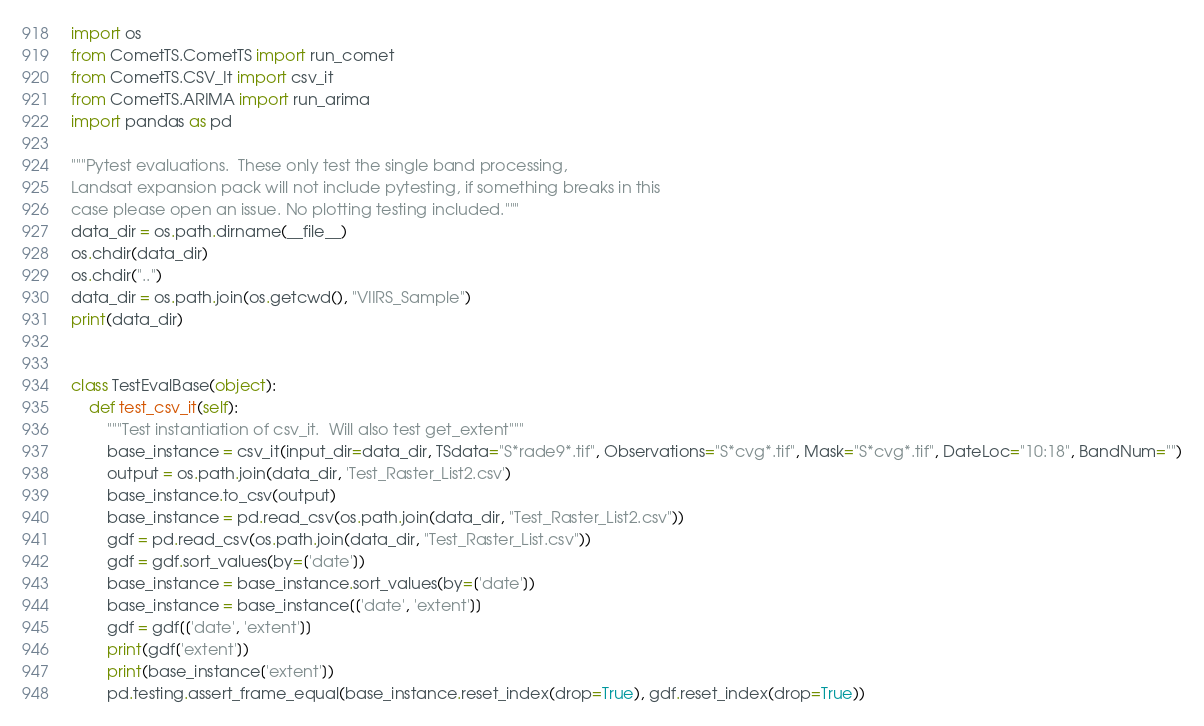Convert code to text. <code><loc_0><loc_0><loc_500><loc_500><_Python_>import os
from CometTS.CometTS import run_comet
from CometTS.CSV_It import csv_it
from CometTS.ARIMA import run_arima
import pandas as pd

"""Pytest evaluations.  These only test the single band processing,
Landsat expansion pack will not include pytesting, if something breaks in this
case please open an issue. No plotting testing included."""
data_dir = os.path.dirname(__file__)
os.chdir(data_dir)
os.chdir("..")
data_dir = os.path.join(os.getcwd(), "VIIRS_Sample")
print(data_dir)


class TestEvalBase(object):
    def test_csv_it(self):
        """Test instantiation of csv_it.  Will also test get_extent"""
        base_instance = csv_it(input_dir=data_dir, TSdata="S*rade9*.tif", Observations="S*cvg*.tif", Mask="S*cvg*.tif", DateLoc="10:18", BandNum="")
        output = os.path.join(data_dir, 'Test_Raster_List2.csv')
        base_instance.to_csv(output)
        base_instance = pd.read_csv(os.path.join(data_dir, "Test_Raster_List2.csv"))
        gdf = pd.read_csv(os.path.join(data_dir, "Test_Raster_List.csv"))
        gdf = gdf.sort_values(by=['date'])
        base_instance = base_instance.sort_values(by=['date'])
        base_instance = base_instance[['date', 'extent']]
        gdf = gdf[['date', 'extent']]
        print(gdf['extent'])
        print(base_instance['extent'])
        pd.testing.assert_frame_equal(base_instance.reset_index(drop=True), gdf.reset_index(drop=True))
</code> 